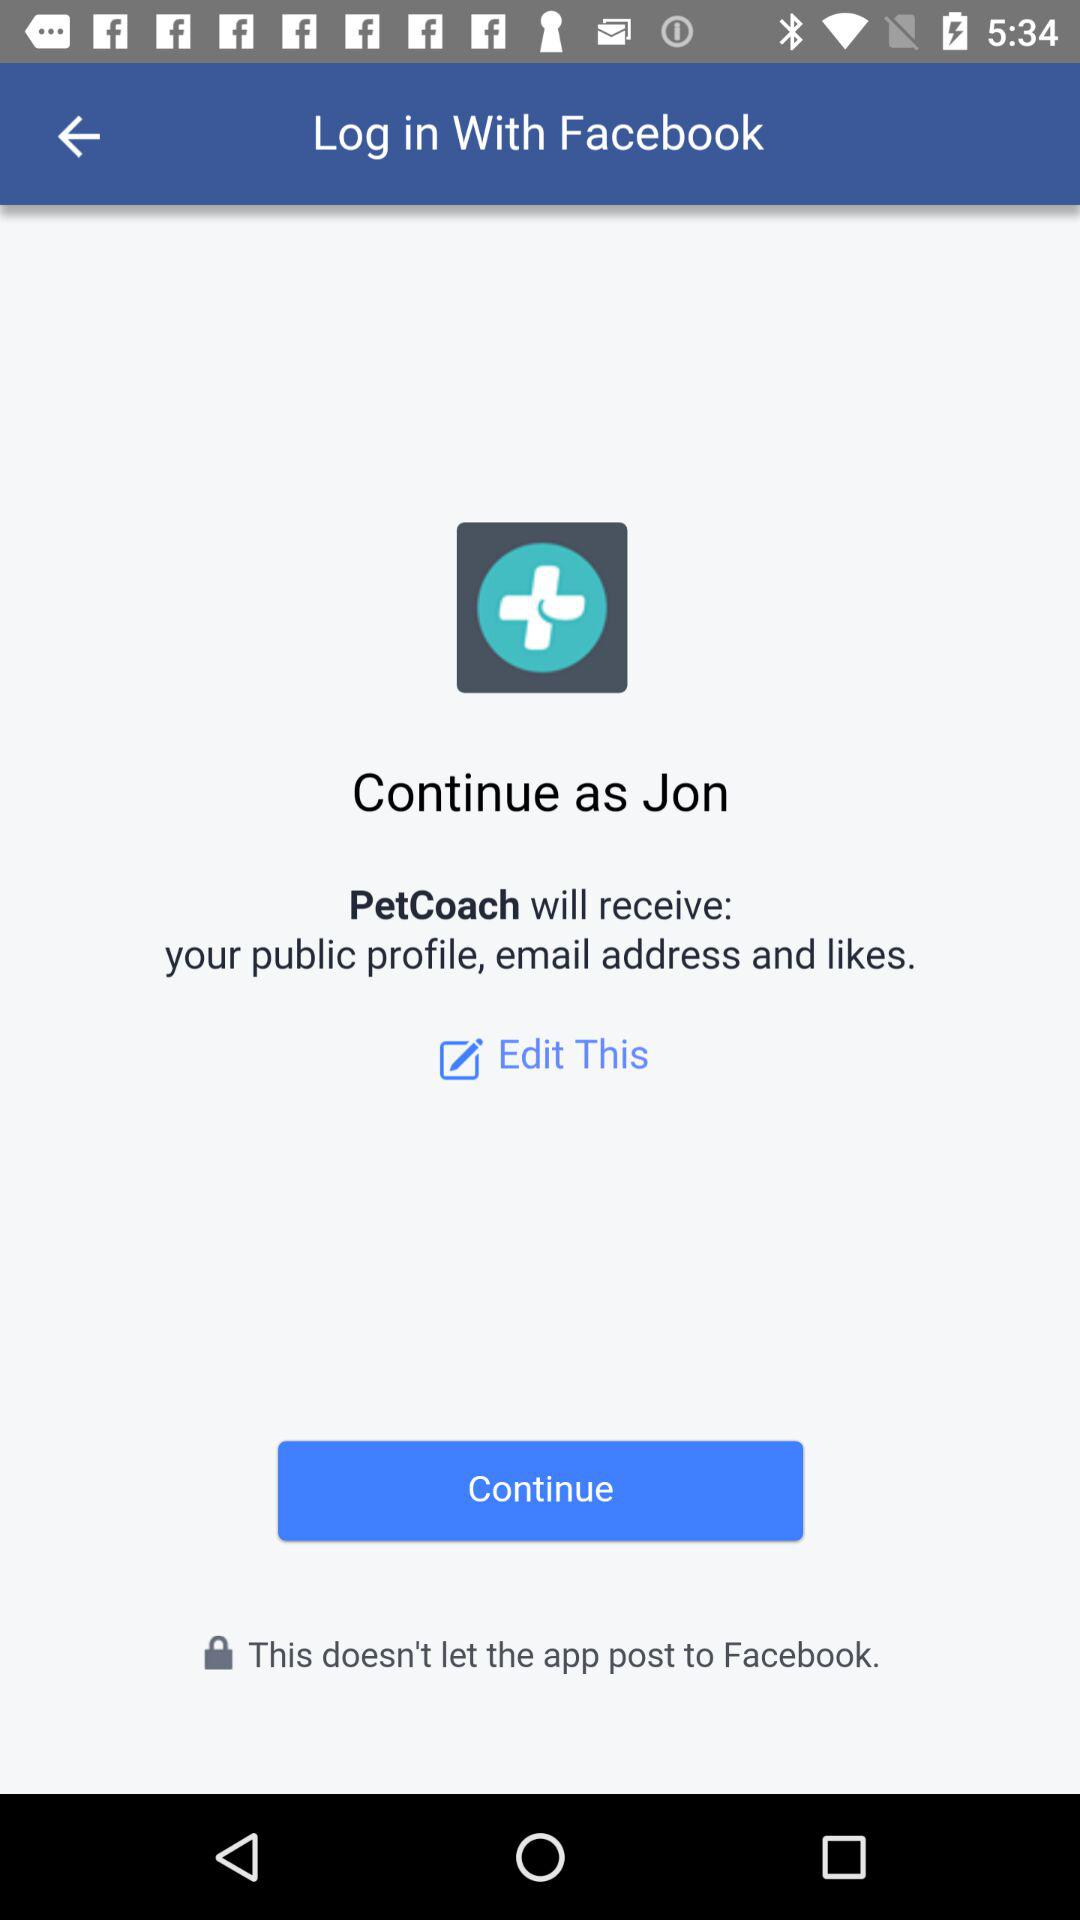What is the login name? The login name is Jon. 